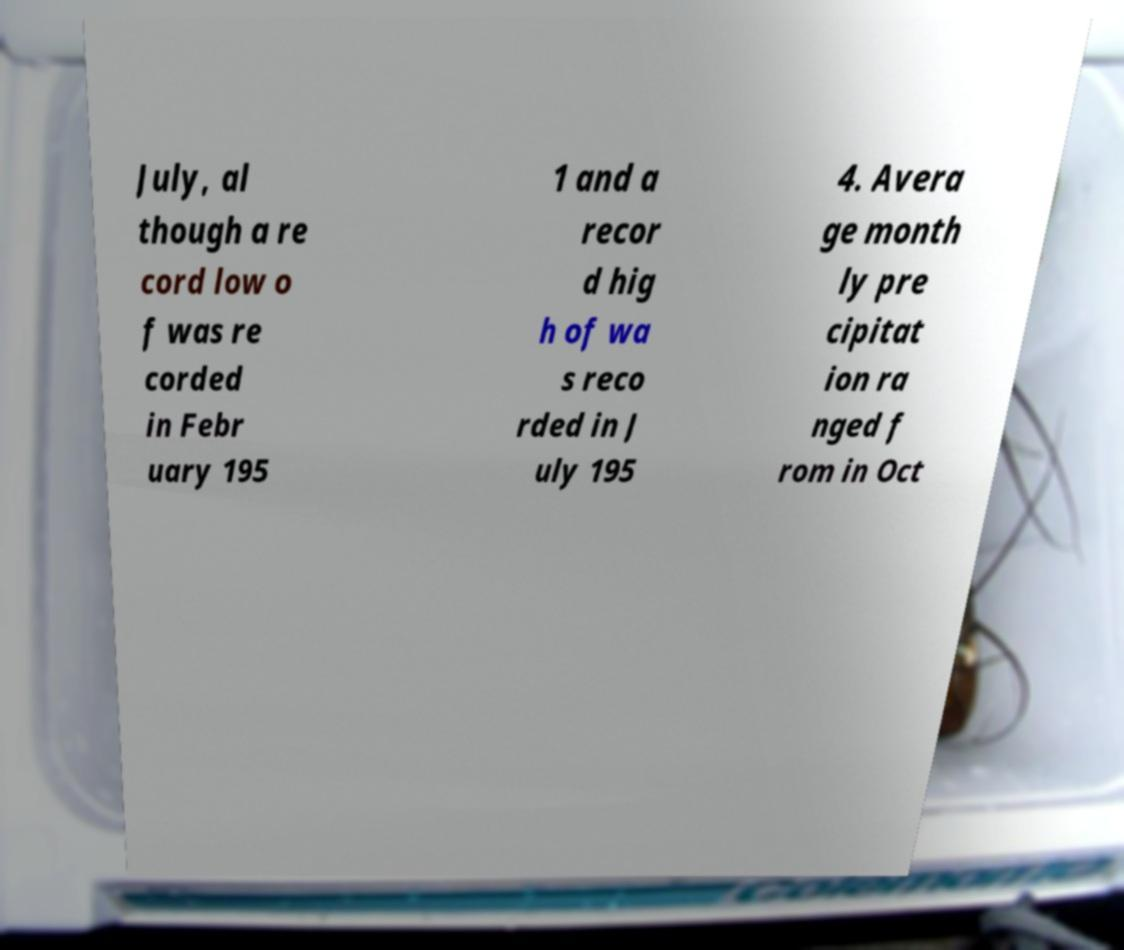What messages or text are displayed in this image? I need them in a readable, typed format. July, al though a re cord low o f was re corded in Febr uary 195 1 and a recor d hig h of wa s reco rded in J uly 195 4. Avera ge month ly pre cipitat ion ra nged f rom in Oct 